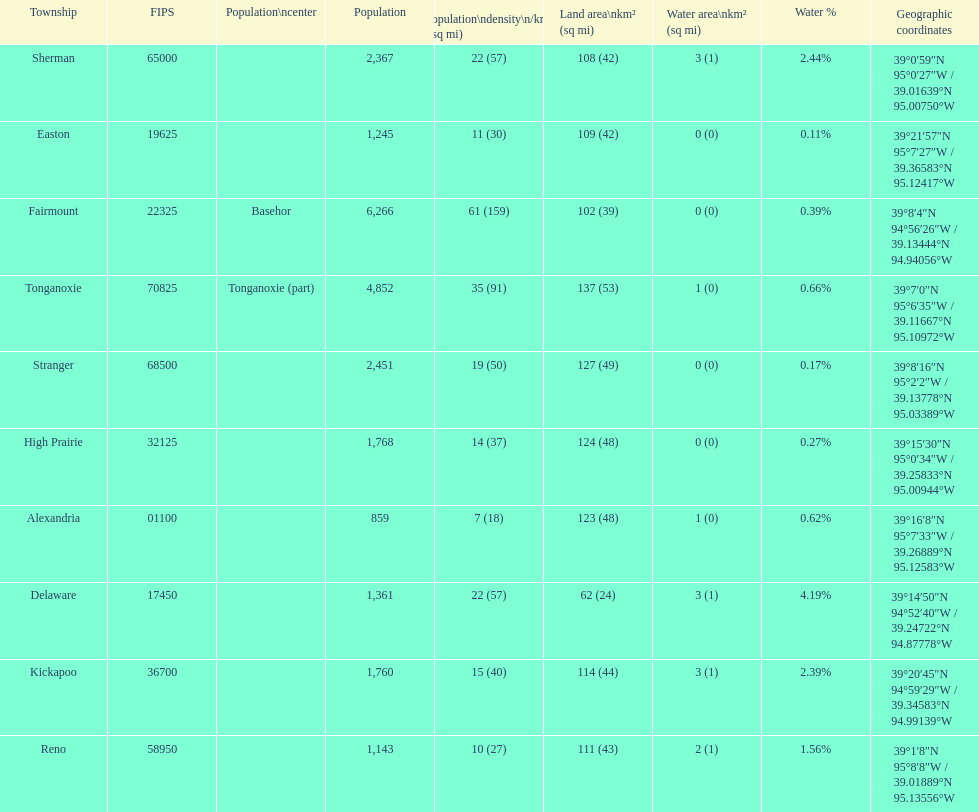What is the number of townships with a population larger than 2,000? 4. 